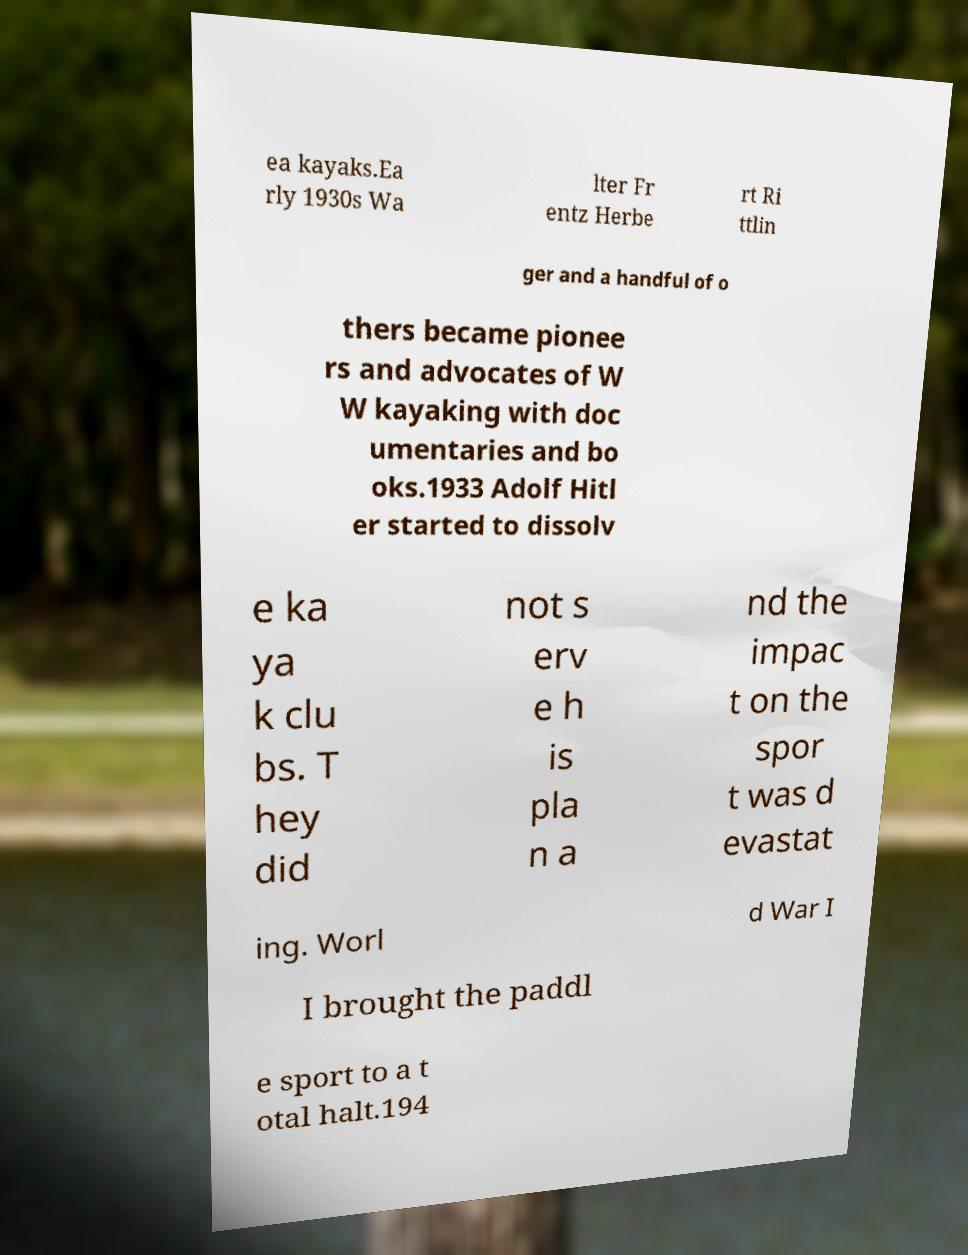Could you extract and type out the text from this image? ea kayaks.Ea rly 1930s Wa lter Fr entz Herbe rt Ri ttlin ger and a handful of o thers became pionee rs and advocates of W W kayaking with doc umentaries and bo oks.1933 Adolf Hitl er started to dissolv e ka ya k clu bs. T hey did not s erv e h is pla n a nd the impac t on the spor t was d evastat ing. Worl d War I I brought the paddl e sport to a t otal halt.194 